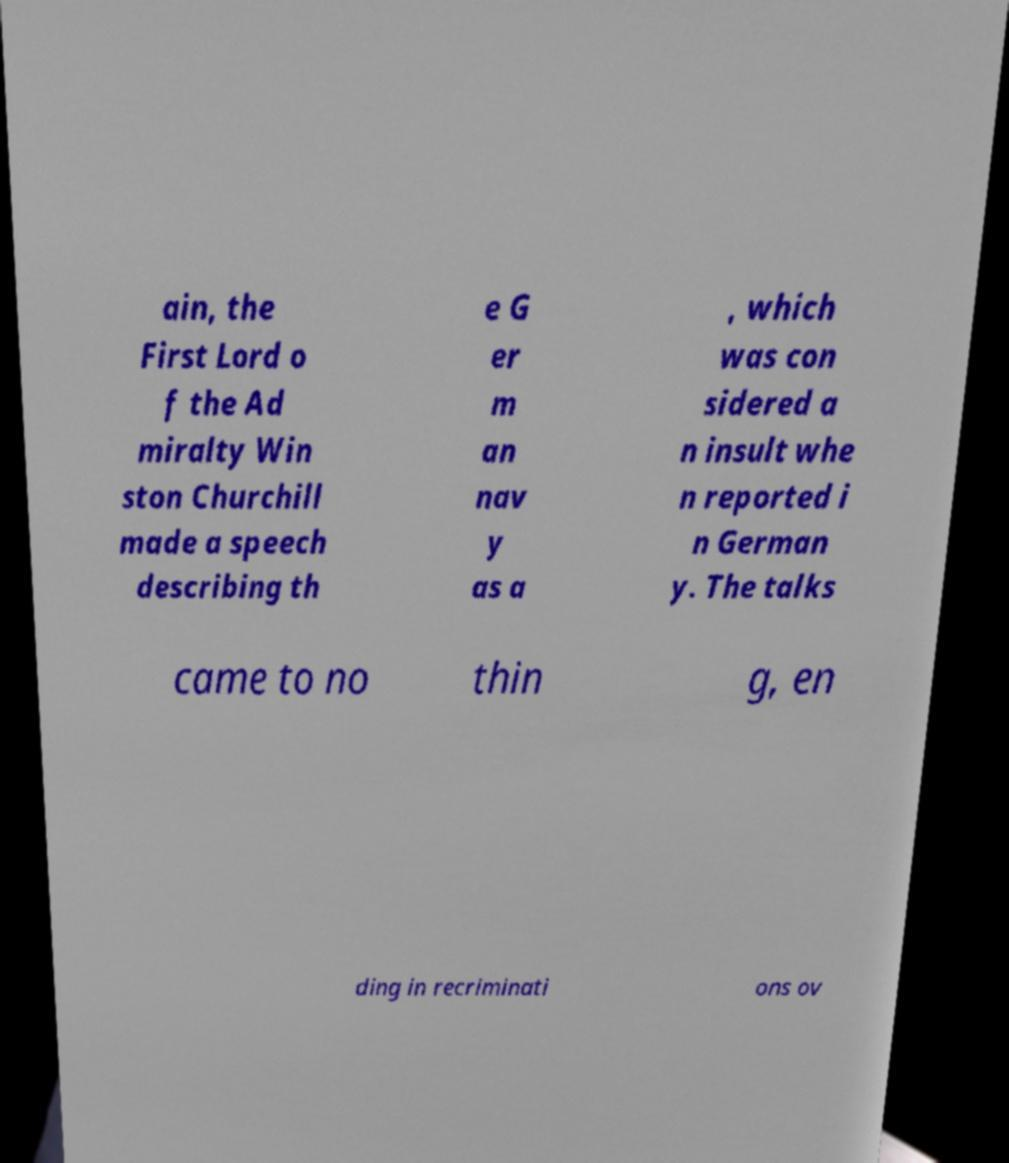Could you extract and type out the text from this image? ain, the First Lord o f the Ad miralty Win ston Churchill made a speech describing th e G er m an nav y as a , which was con sidered a n insult whe n reported i n German y. The talks came to no thin g, en ding in recriminati ons ov 